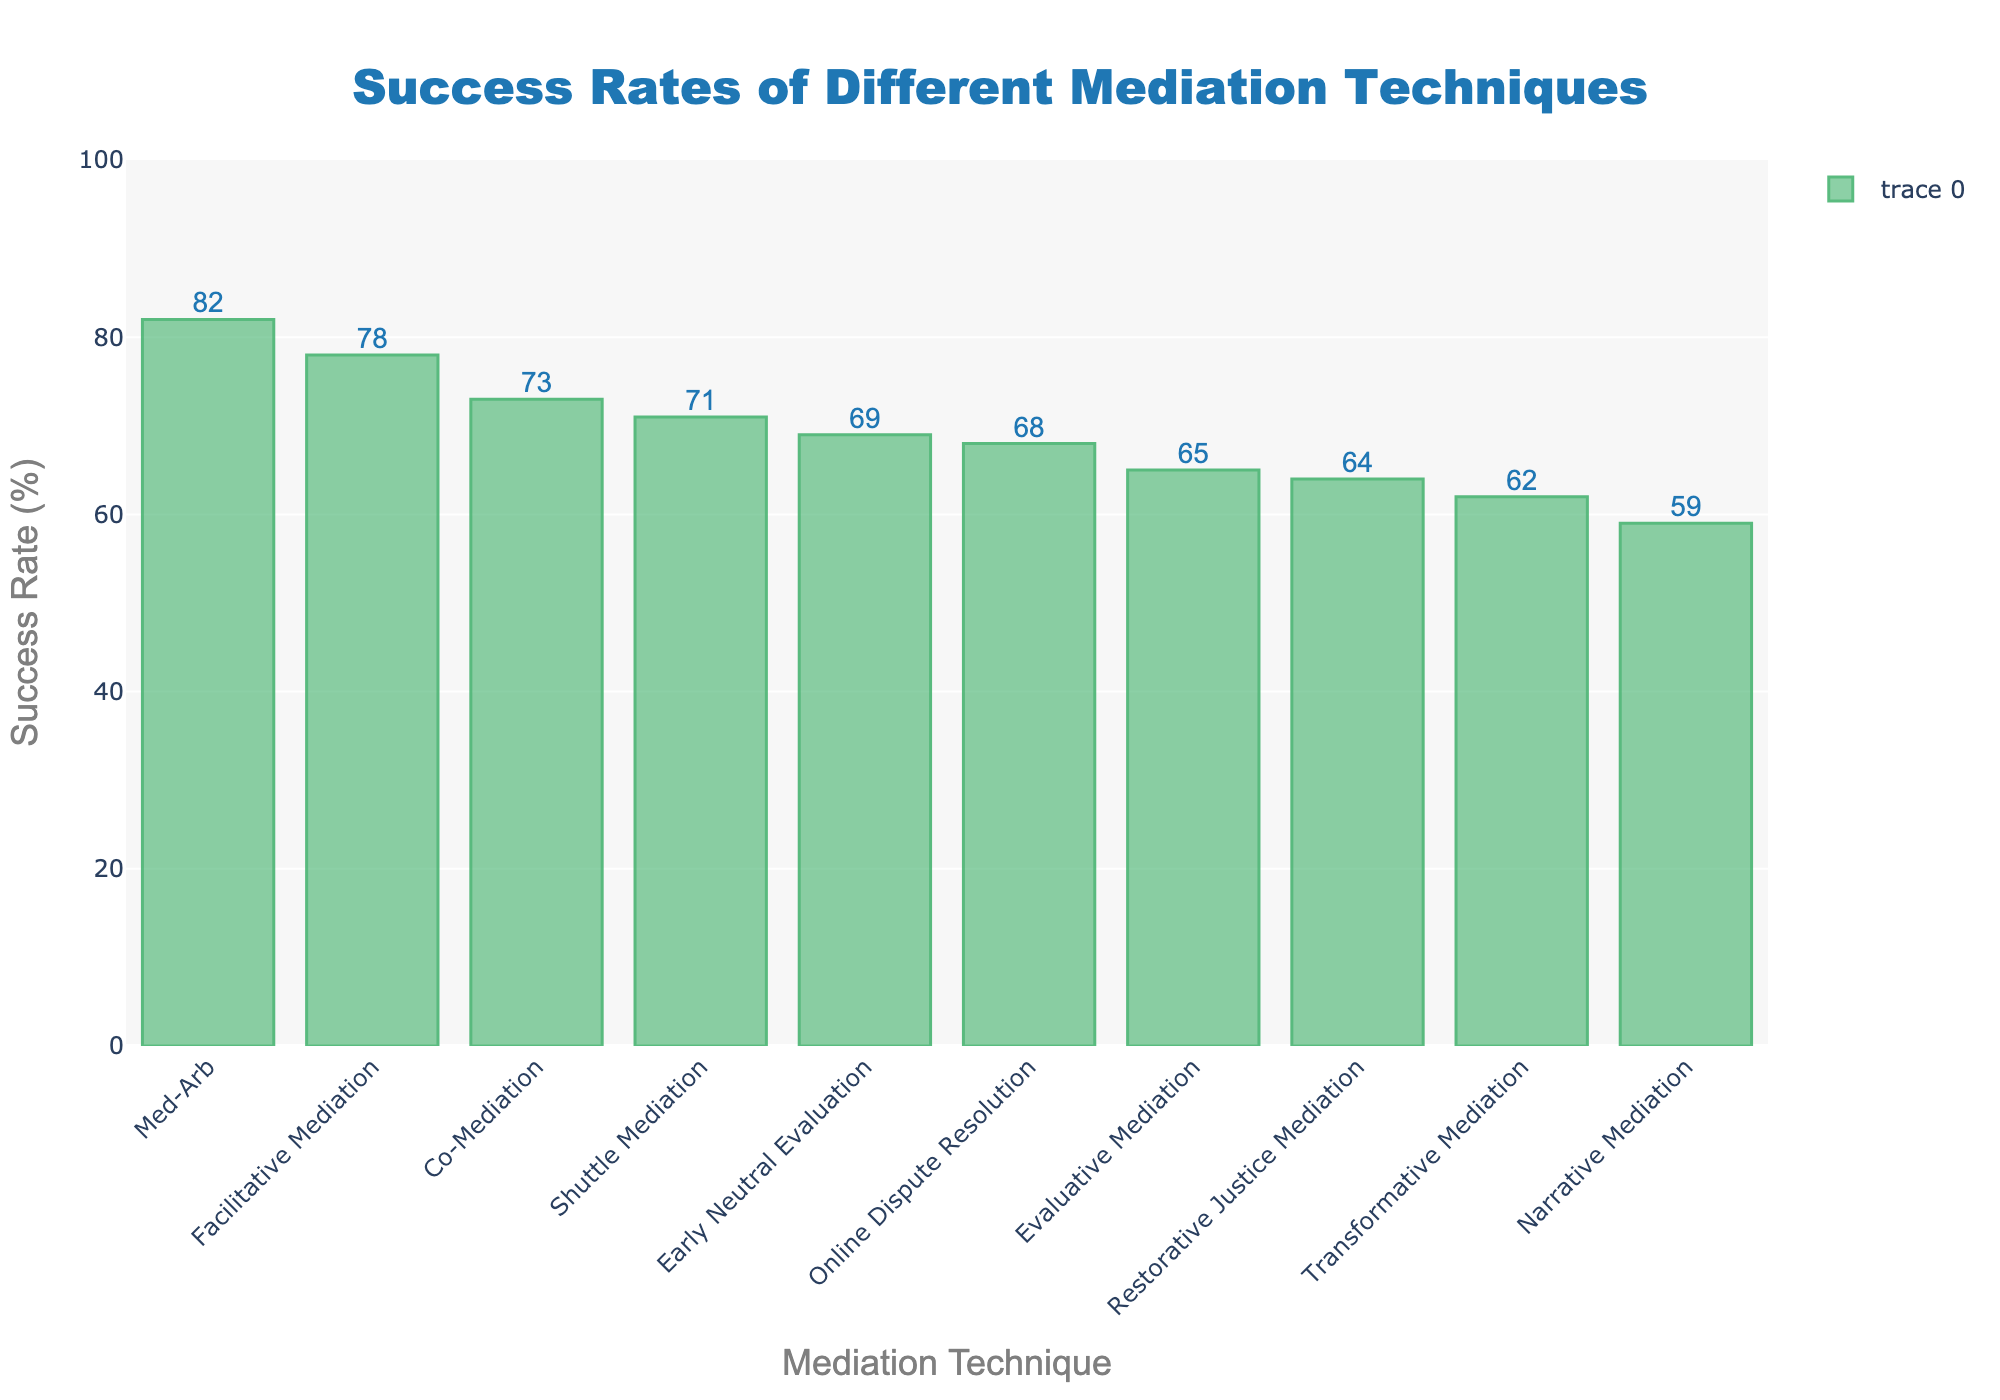What's the success rate of the most effective mediation technique? Look for the bar with the highest value. The highest success rate is for Med-Arb, which has an 82% success rate.
Answer: 82% Which mediation technique has the lowest success rate? Look for the bar with the lowest value. The lowest success rate is for Narrative Mediation, which is 59%.
Answer: 59% How much higher is the success rate of Facilitative Mediation compared to Transformative Mediation? Find the heights of the bars for Facilitative Mediation and Transformative Mediation, then subtract the lower value from the higher one. Facilitative Mediation is 78% and Transformative Mediation is 62%, so 78 - 62 = 16.
Answer: 16% What is the average success rate of evaluative mediation and shuttle mediation combined? Calculate the average of the success rates of Evaluative Mediation (65%) and Shuttle Mediation (71%). Average = (65 + 71) / 2 = 68.
Answer: 68 Which techniques have a success rate greater than 70% but less than 80%? Identify bars with heights between 70% and 80%. These techniques are Facilitative Mediation (78%), Shuttle Mediation (71%), and Co-Mediation (73%).
Answer: Facilitative Mediation, Shuttle Mediation, Co-Mediation If we combine the success rates of Early Neutral Evaluation and Restorative Justice Mediation, what is the total? Sum the success rates of Early Neutral Evaluation (69%) and Restorative Justice Mediation (64%). Total = 69 + 64 = 133.
Answer: 133 What is the difference between the highest and lowest success rates among the techniques? Subtract the lowest success rate from the highest one. Highest is Med-Arb (82%) and lowest is Narrative Mediation (59%), so 82 - 59 = 23.
Answer: 23 Which mediation techniques have success rates closest to the average of all techniques? Calculate the average success rate of all presented techniques. Sum all success rates and divide by the number of techniques. Average = (78 + 65 + 62 + 59 + 71 + 68 + 73 + 82 + 69 + 64) / 10 = 69.1. Techniques closest to this average are Early Neutral Evaluation (69%) and Online Dispute Resolution (68%).
Answer: Early Neutral Evaluation, Online Dispute Resolution 